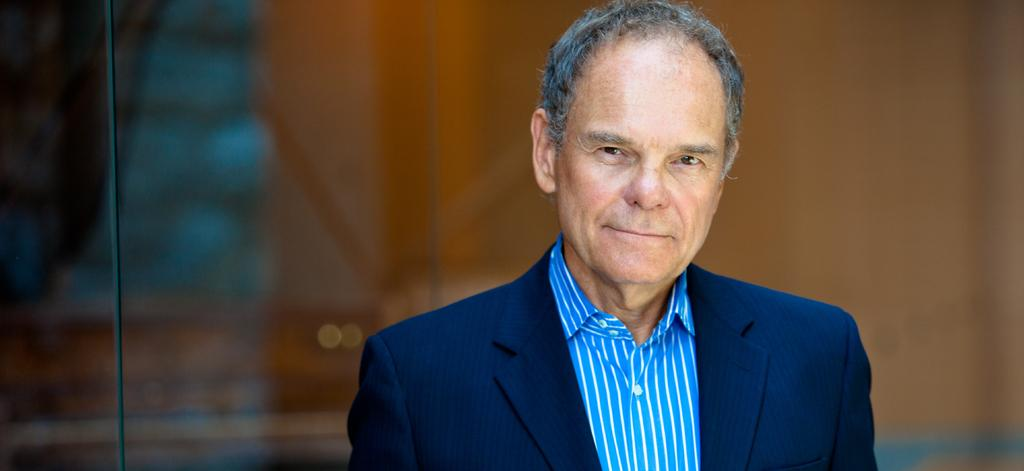Who is present in the image? There is a man in the image. What is the man wearing? The man is wearing a suit. Can you describe the background of the image? The background of the image is not clear. Where might the image have been taken? The image may have been taken in a hall. Is the man in the image helping someone with a wound? There is no indication of a wound or someone needing help in the image; it only shows a man wearing a suit. 